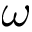<formula> <loc_0><loc_0><loc_500><loc_500>\omega</formula> 